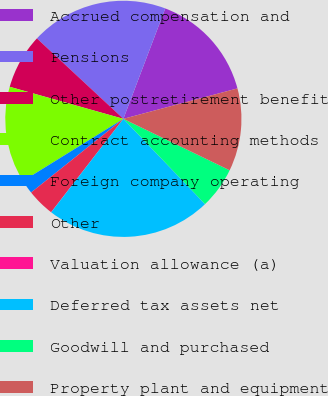<chart> <loc_0><loc_0><loc_500><loc_500><pie_chart><fcel>Accrued compensation and<fcel>Pensions<fcel>Other postretirement benefit<fcel>Contract accounting methods<fcel>Foreign company operating<fcel>Other<fcel>Valuation allowance (a)<fcel>Deferred tax assets net<fcel>Goodwill and purchased<fcel>Property plant and equipment<nl><fcel>15.08%<fcel>18.85%<fcel>7.55%<fcel>13.2%<fcel>1.9%<fcel>3.79%<fcel>0.02%<fcel>22.62%<fcel>5.67%<fcel>11.32%<nl></chart> 